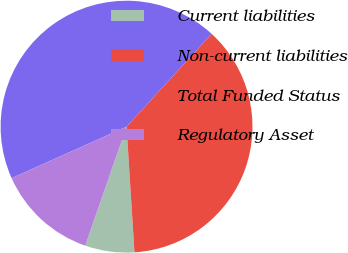Convert chart to OTSL. <chart><loc_0><loc_0><loc_500><loc_500><pie_chart><fcel>Current liabilities<fcel>Non-current liabilities<fcel>Total Funded Status<fcel>Regulatory Asset<nl><fcel>6.32%<fcel>37.19%<fcel>43.51%<fcel>12.98%<nl></chart> 